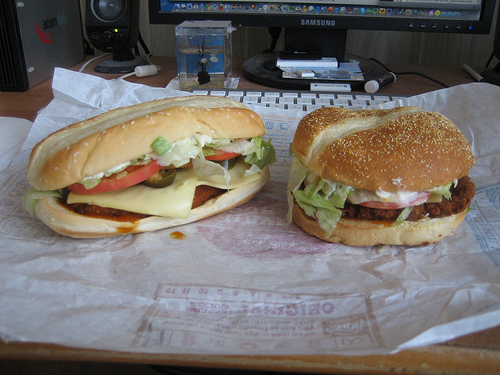Please provide a short description for this region: [0.14, 0.45, 0.2, 0.52]. A small piece of green lettuce nestled under the hamburger bun, adding a fresh and healthy aspect to the meal. 